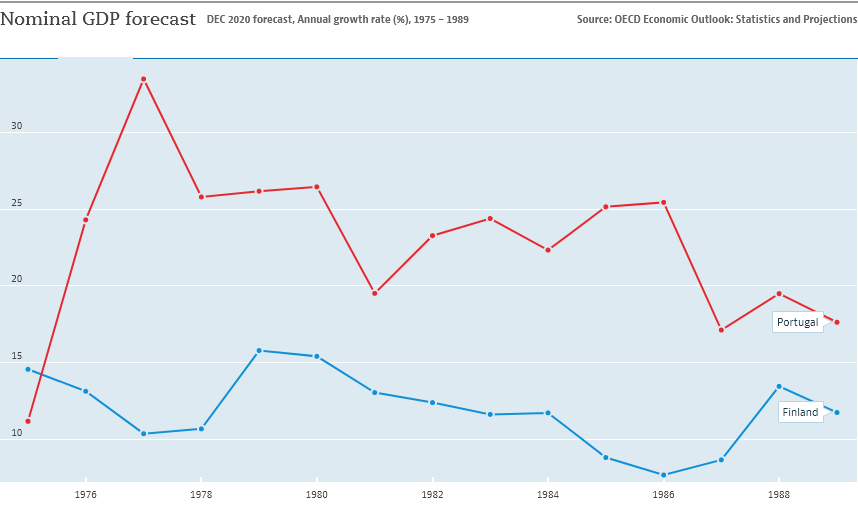Point out several critical features in this image. The line graph of Portugal shows a peak in the year 1976. The graph compares the GDP per capita of two countries, Portugal and Finland. 